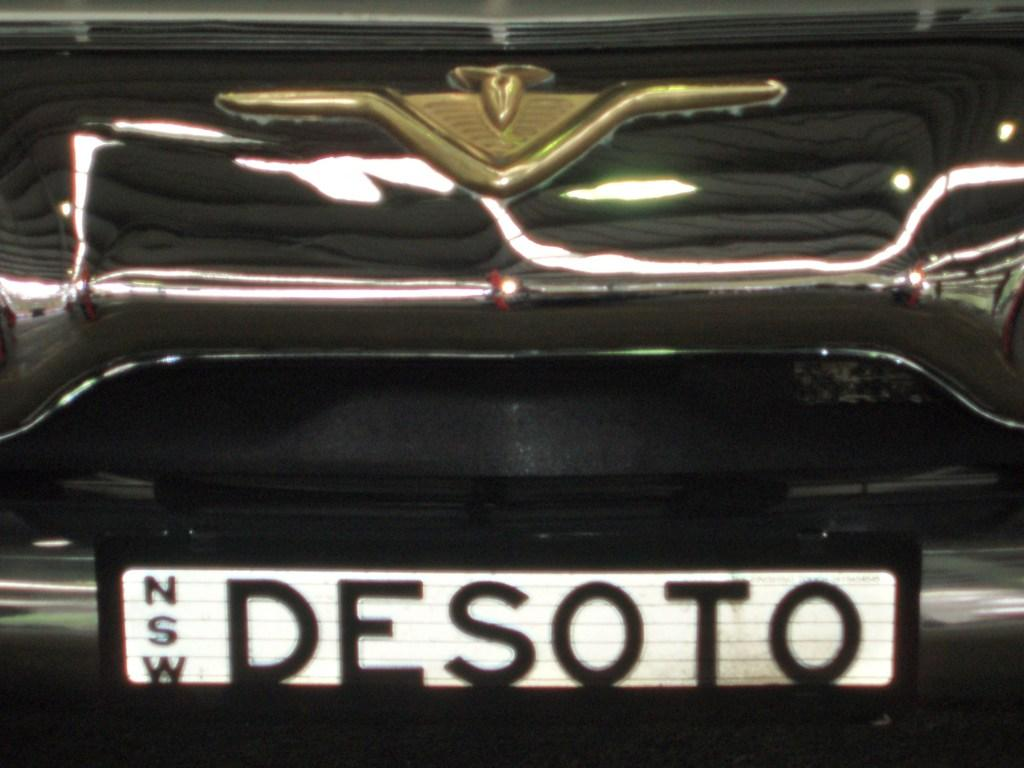<image>
Write a terse but informative summary of the picture. A luxury black vehicle with the license plate Desoto. 